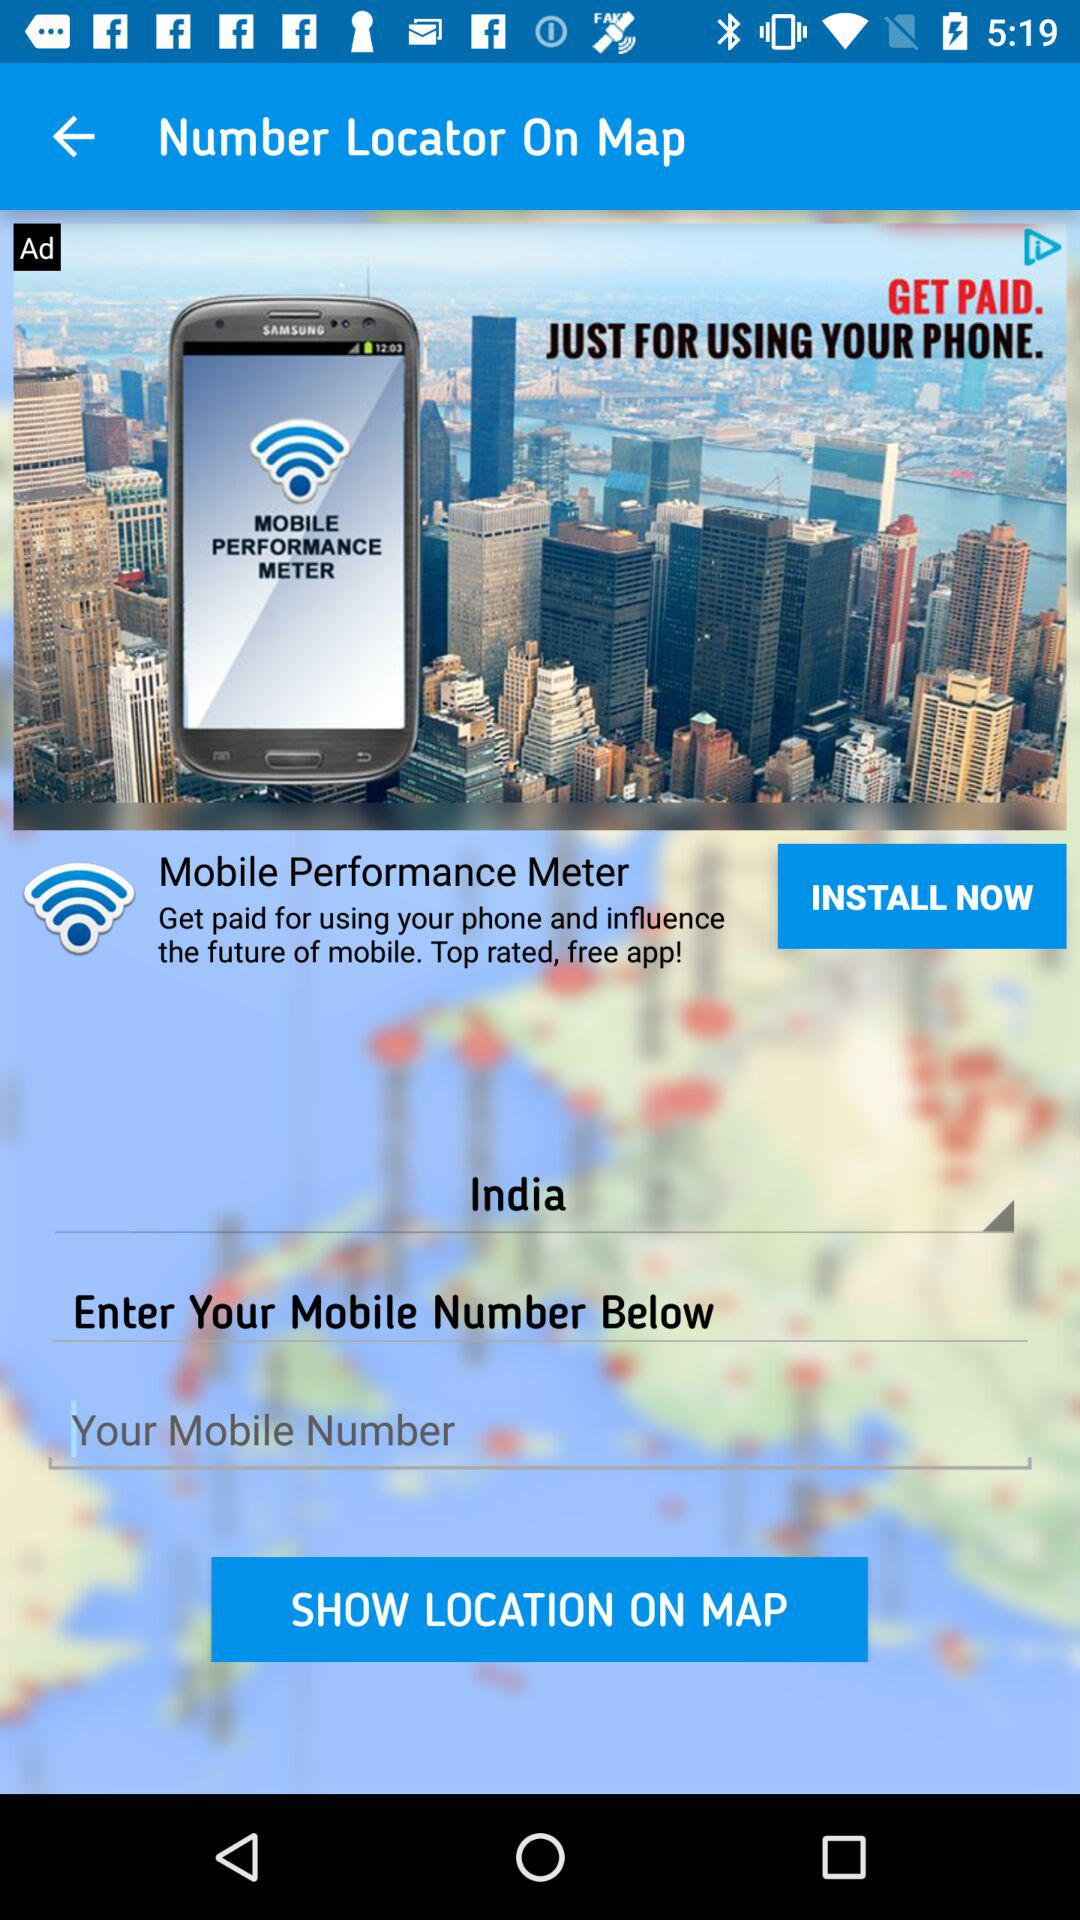Which location is selected? The selected location is India. 